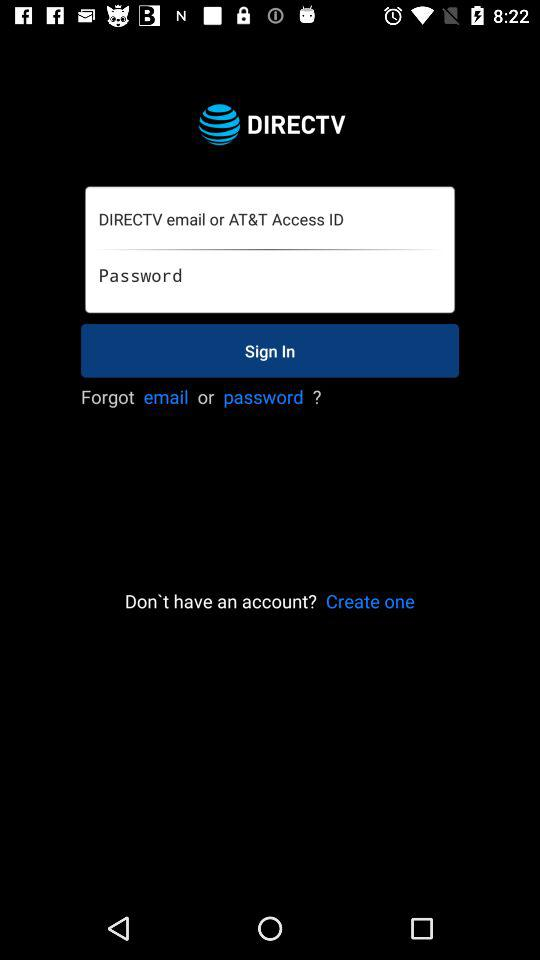What is the name of the application? The name of the application is "DIRECTV". 